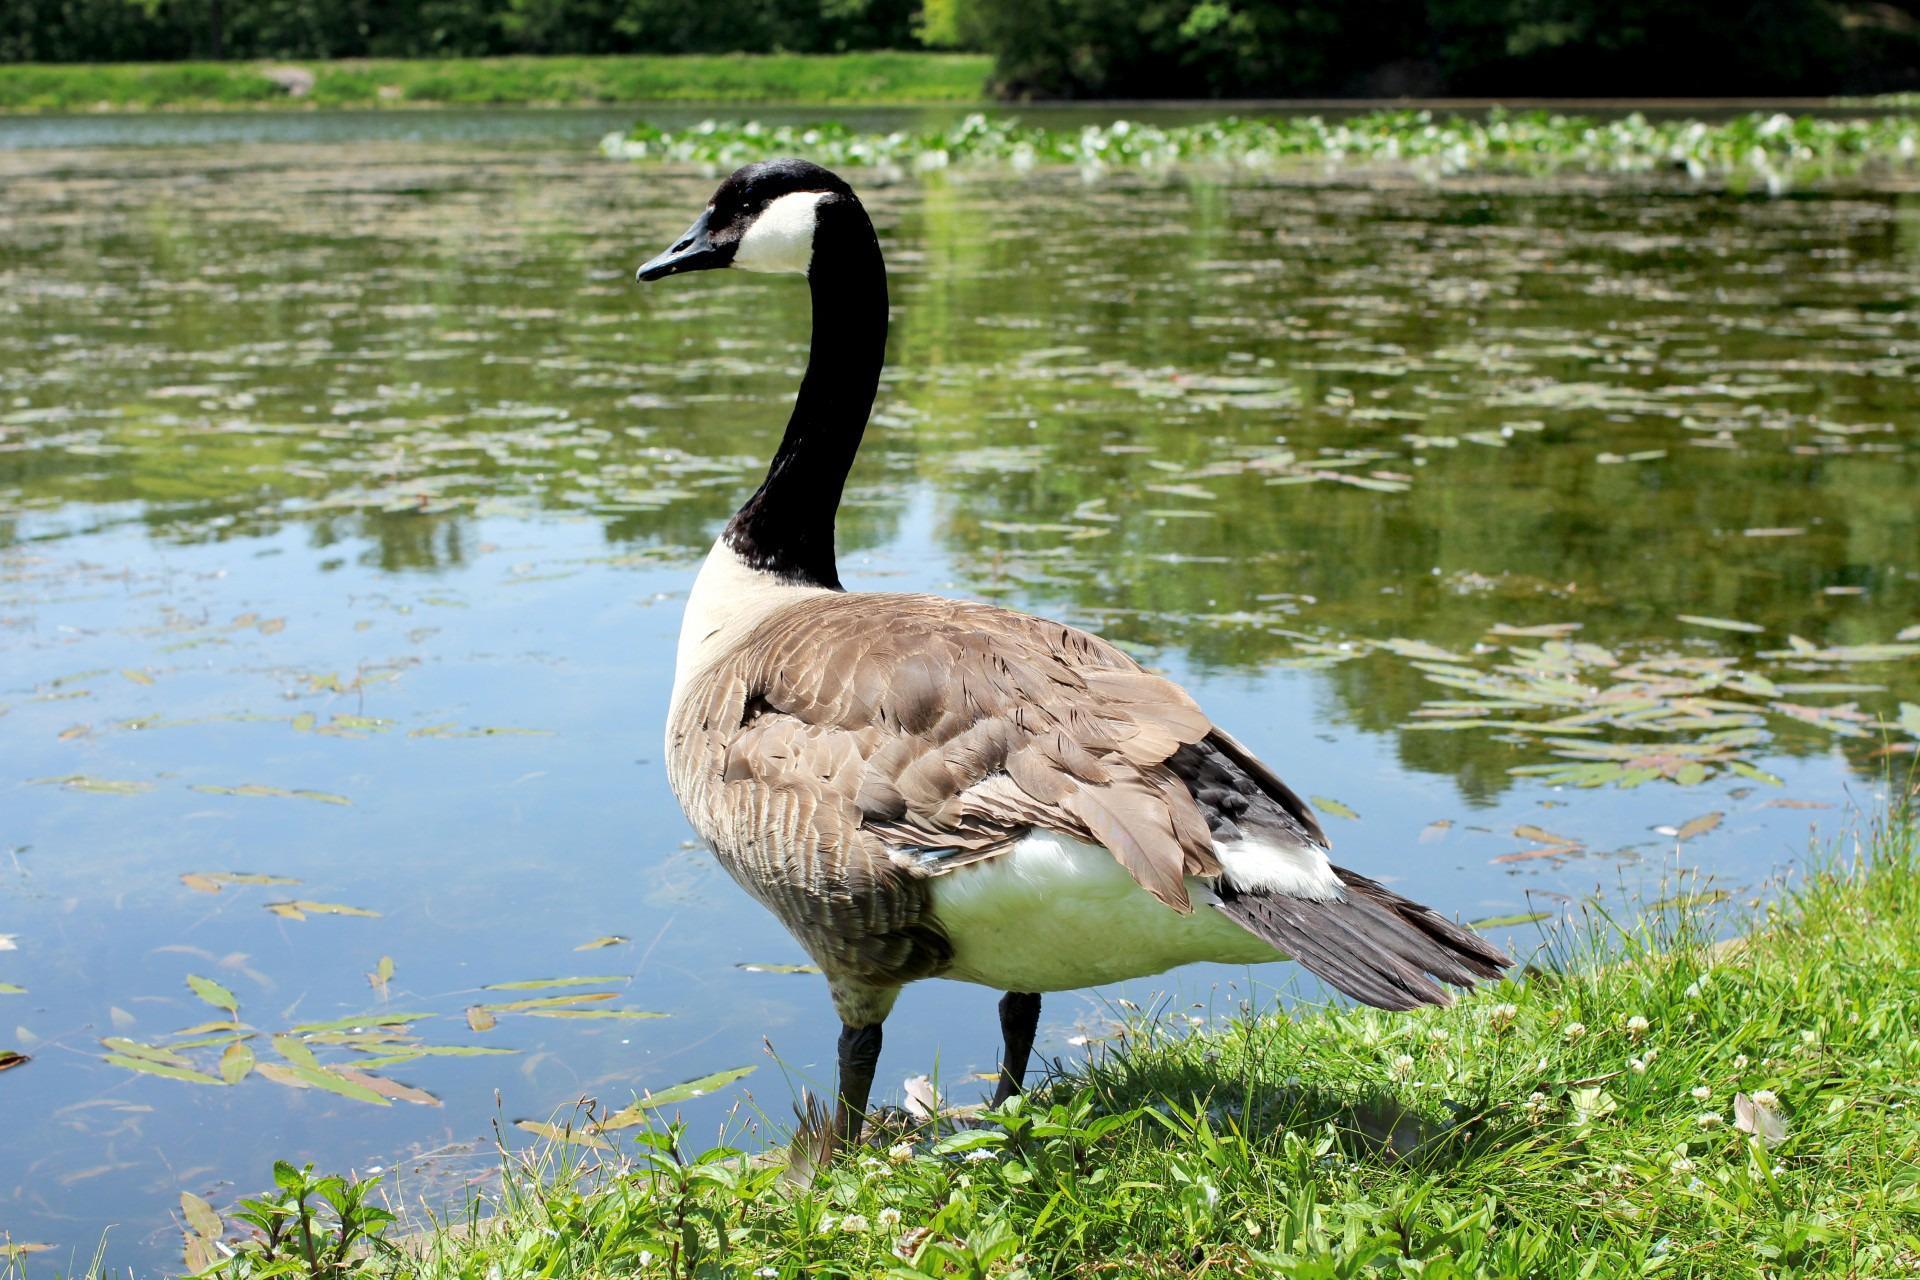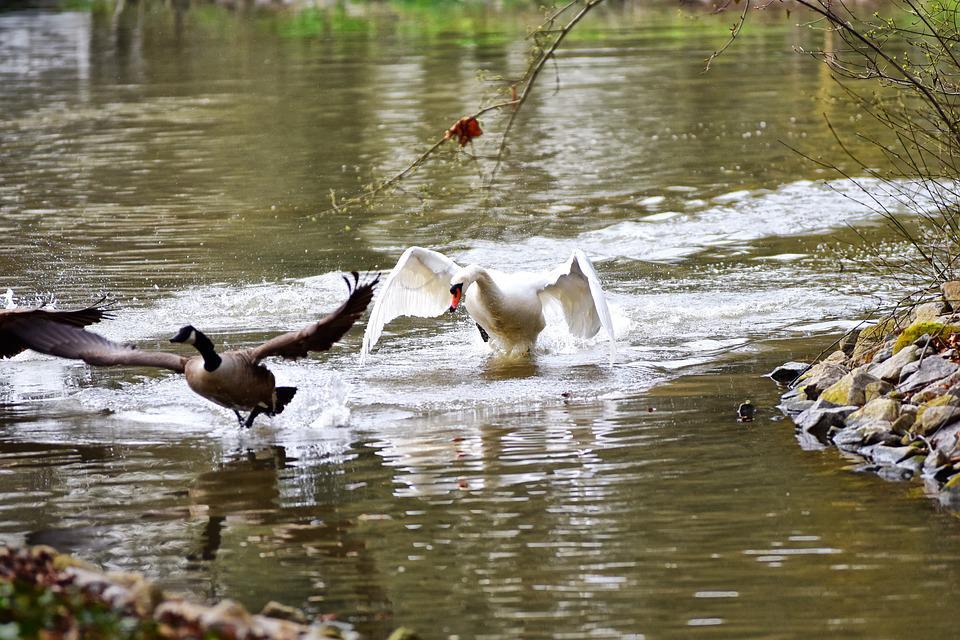The first image is the image on the left, the second image is the image on the right. For the images displayed, is the sentence "One image contains at least one swan, and the other image contains at least one goose." factually correct? Answer yes or no. Yes. The first image is the image on the left, the second image is the image on the right. For the images displayed, is the sentence "Every single image features more than one bird." factually correct? Answer yes or no. No. 